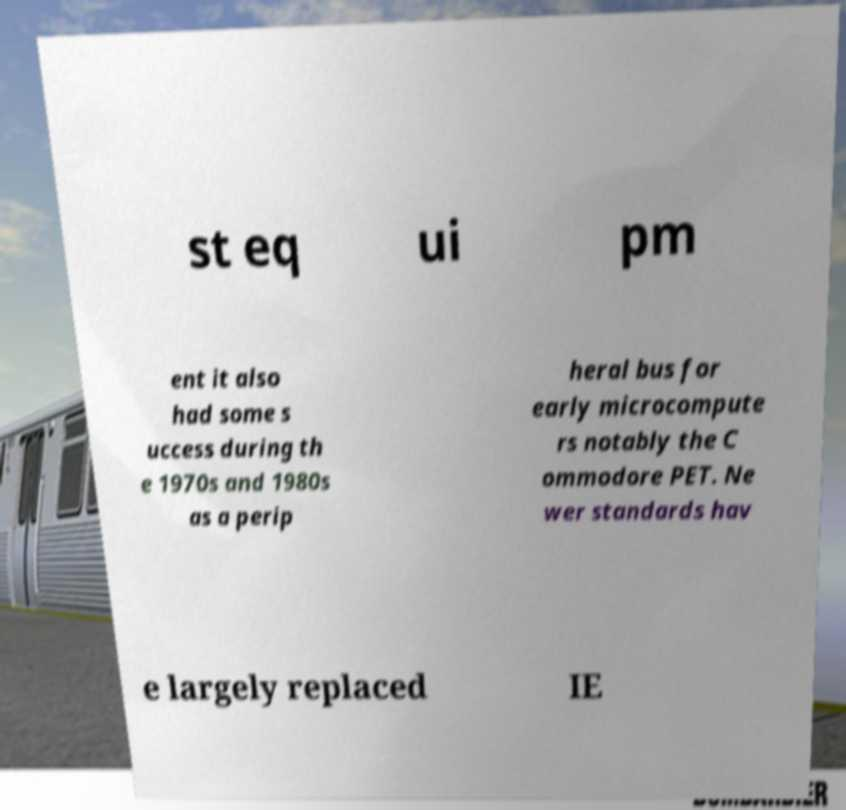Can you accurately transcribe the text from the provided image for me? st eq ui pm ent it also had some s uccess during th e 1970s and 1980s as a perip heral bus for early microcompute rs notably the C ommodore PET. Ne wer standards hav e largely replaced IE 